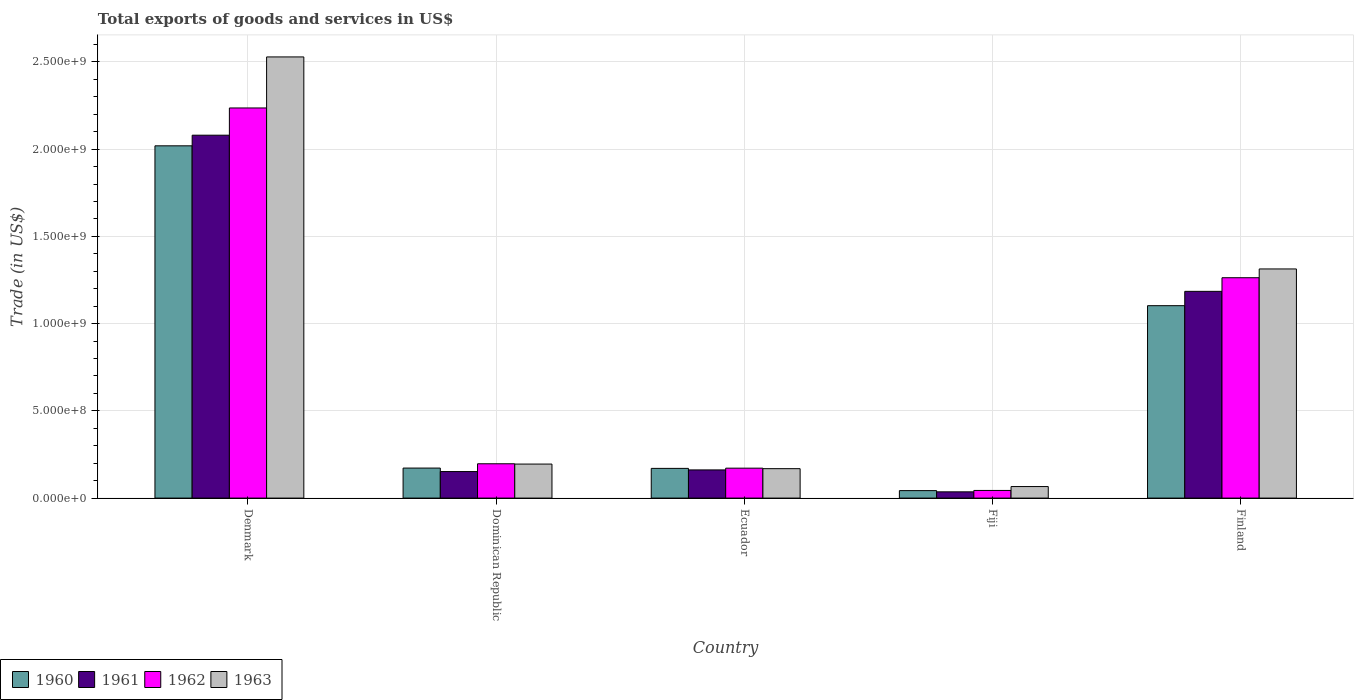How many different coloured bars are there?
Your answer should be compact. 4. How many groups of bars are there?
Offer a very short reply. 5. Are the number of bars on each tick of the X-axis equal?
Ensure brevity in your answer.  Yes. How many bars are there on the 3rd tick from the left?
Offer a terse response. 4. How many bars are there on the 2nd tick from the right?
Your response must be concise. 4. In how many cases, is the number of bars for a given country not equal to the number of legend labels?
Offer a very short reply. 0. What is the total exports of goods and services in 1962 in Fiji?
Make the answer very short. 4.38e+07. Across all countries, what is the maximum total exports of goods and services in 1962?
Provide a short and direct response. 2.24e+09. Across all countries, what is the minimum total exports of goods and services in 1961?
Provide a succinct answer. 3.59e+07. In which country was the total exports of goods and services in 1962 minimum?
Give a very brief answer. Fiji. What is the total total exports of goods and services in 1962 in the graph?
Keep it short and to the point. 3.91e+09. What is the difference between the total exports of goods and services in 1961 in Ecuador and that in Fiji?
Your answer should be very brief. 1.26e+08. What is the difference between the total exports of goods and services in 1963 in Ecuador and the total exports of goods and services in 1960 in Denmark?
Offer a very short reply. -1.85e+09. What is the average total exports of goods and services in 1961 per country?
Provide a succinct answer. 7.23e+08. What is the difference between the total exports of goods and services of/in 1960 and total exports of goods and services of/in 1962 in Denmark?
Give a very brief answer. -2.17e+08. What is the ratio of the total exports of goods and services in 1962 in Denmark to that in Dominican Republic?
Ensure brevity in your answer.  11.37. Is the difference between the total exports of goods and services in 1960 in Dominican Republic and Finland greater than the difference between the total exports of goods and services in 1962 in Dominican Republic and Finland?
Provide a succinct answer. Yes. What is the difference between the highest and the second highest total exports of goods and services in 1960?
Offer a very short reply. -9.31e+08. What is the difference between the highest and the lowest total exports of goods and services in 1960?
Your answer should be very brief. 1.98e+09. In how many countries, is the total exports of goods and services in 1961 greater than the average total exports of goods and services in 1961 taken over all countries?
Keep it short and to the point. 2. Is the sum of the total exports of goods and services in 1961 in Fiji and Finland greater than the maximum total exports of goods and services in 1963 across all countries?
Make the answer very short. No. Is it the case that in every country, the sum of the total exports of goods and services in 1962 and total exports of goods and services in 1961 is greater than the sum of total exports of goods and services in 1960 and total exports of goods and services in 1963?
Your answer should be very brief. No. What does the 3rd bar from the right in Finland represents?
Ensure brevity in your answer.  1961. How many bars are there?
Offer a terse response. 20. Does the graph contain any zero values?
Make the answer very short. No. Does the graph contain grids?
Your answer should be very brief. Yes. Where does the legend appear in the graph?
Provide a succinct answer. Bottom left. How are the legend labels stacked?
Keep it short and to the point. Horizontal. What is the title of the graph?
Provide a succinct answer. Total exports of goods and services in US$. What is the label or title of the Y-axis?
Your response must be concise. Trade (in US$). What is the Trade (in US$) in 1960 in Denmark?
Ensure brevity in your answer.  2.02e+09. What is the Trade (in US$) of 1961 in Denmark?
Provide a short and direct response. 2.08e+09. What is the Trade (in US$) in 1962 in Denmark?
Offer a terse response. 2.24e+09. What is the Trade (in US$) in 1963 in Denmark?
Offer a terse response. 2.53e+09. What is the Trade (in US$) in 1960 in Dominican Republic?
Ensure brevity in your answer.  1.72e+08. What is the Trade (in US$) in 1961 in Dominican Republic?
Make the answer very short. 1.52e+08. What is the Trade (in US$) in 1962 in Dominican Republic?
Your response must be concise. 1.97e+08. What is the Trade (in US$) in 1963 in Dominican Republic?
Give a very brief answer. 1.95e+08. What is the Trade (in US$) in 1960 in Ecuador?
Provide a short and direct response. 1.70e+08. What is the Trade (in US$) of 1961 in Ecuador?
Offer a very short reply. 1.61e+08. What is the Trade (in US$) of 1962 in Ecuador?
Offer a very short reply. 1.71e+08. What is the Trade (in US$) in 1963 in Ecuador?
Make the answer very short. 1.69e+08. What is the Trade (in US$) in 1960 in Fiji?
Offer a terse response. 4.28e+07. What is the Trade (in US$) of 1961 in Fiji?
Provide a succinct answer. 3.59e+07. What is the Trade (in US$) in 1962 in Fiji?
Offer a very short reply. 4.38e+07. What is the Trade (in US$) in 1963 in Fiji?
Your answer should be very brief. 6.61e+07. What is the Trade (in US$) in 1960 in Finland?
Your response must be concise. 1.10e+09. What is the Trade (in US$) in 1961 in Finland?
Offer a terse response. 1.18e+09. What is the Trade (in US$) in 1962 in Finland?
Your response must be concise. 1.26e+09. What is the Trade (in US$) of 1963 in Finland?
Provide a short and direct response. 1.31e+09. Across all countries, what is the maximum Trade (in US$) in 1960?
Keep it short and to the point. 2.02e+09. Across all countries, what is the maximum Trade (in US$) in 1961?
Provide a short and direct response. 2.08e+09. Across all countries, what is the maximum Trade (in US$) of 1962?
Give a very brief answer. 2.24e+09. Across all countries, what is the maximum Trade (in US$) in 1963?
Keep it short and to the point. 2.53e+09. Across all countries, what is the minimum Trade (in US$) of 1960?
Ensure brevity in your answer.  4.28e+07. Across all countries, what is the minimum Trade (in US$) of 1961?
Provide a short and direct response. 3.59e+07. Across all countries, what is the minimum Trade (in US$) in 1962?
Make the answer very short. 4.38e+07. Across all countries, what is the minimum Trade (in US$) in 1963?
Provide a short and direct response. 6.61e+07. What is the total Trade (in US$) of 1960 in the graph?
Offer a very short reply. 3.51e+09. What is the total Trade (in US$) of 1961 in the graph?
Your answer should be compact. 3.61e+09. What is the total Trade (in US$) of 1962 in the graph?
Your answer should be very brief. 3.91e+09. What is the total Trade (in US$) in 1963 in the graph?
Your answer should be very brief. 4.27e+09. What is the difference between the Trade (in US$) of 1960 in Denmark and that in Dominican Republic?
Offer a very short reply. 1.85e+09. What is the difference between the Trade (in US$) in 1961 in Denmark and that in Dominican Republic?
Your answer should be compact. 1.93e+09. What is the difference between the Trade (in US$) of 1962 in Denmark and that in Dominican Republic?
Make the answer very short. 2.04e+09. What is the difference between the Trade (in US$) in 1963 in Denmark and that in Dominican Republic?
Offer a very short reply. 2.33e+09. What is the difference between the Trade (in US$) of 1960 in Denmark and that in Ecuador?
Offer a very short reply. 1.85e+09. What is the difference between the Trade (in US$) of 1961 in Denmark and that in Ecuador?
Provide a short and direct response. 1.92e+09. What is the difference between the Trade (in US$) of 1962 in Denmark and that in Ecuador?
Your response must be concise. 2.06e+09. What is the difference between the Trade (in US$) of 1963 in Denmark and that in Ecuador?
Your response must be concise. 2.36e+09. What is the difference between the Trade (in US$) of 1960 in Denmark and that in Fiji?
Provide a succinct answer. 1.98e+09. What is the difference between the Trade (in US$) of 1961 in Denmark and that in Fiji?
Keep it short and to the point. 2.04e+09. What is the difference between the Trade (in US$) in 1962 in Denmark and that in Fiji?
Keep it short and to the point. 2.19e+09. What is the difference between the Trade (in US$) in 1963 in Denmark and that in Fiji?
Keep it short and to the point. 2.46e+09. What is the difference between the Trade (in US$) in 1960 in Denmark and that in Finland?
Ensure brevity in your answer.  9.16e+08. What is the difference between the Trade (in US$) of 1961 in Denmark and that in Finland?
Make the answer very short. 8.95e+08. What is the difference between the Trade (in US$) in 1962 in Denmark and that in Finland?
Your answer should be very brief. 9.73e+08. What is the difference between the Trade (in US$) of 1963 in Denmark and that in Finland?
Keep it short and to the point. 1.22e+09. What is the difference between the Trade (in US$) in 1960 in Dominican Republic and that in Ecuador?
Offer a terse response. 1.84e+06. What is the difference between the Trade (in US$) in 1961 in Dominican Republic and that in Ecuador?
Keep it short and to the point. -9.39e+06. What is the difference between the Trade (in US$) in 1962 in Dominican Republic and that in Ecuador?
Your response must be concise. 2.52e+07. What is the difference between the Trade (in US$) of 1963 in Dominican Republic and that in Ecuador?
Your response must be concise. 2.63e+07. What is the difference between the Trade (in US$) in 1960 in Dominican Republic and that in Fiji?
Provide a succinct answer. 1.29e+08. What is the difference between the Trade (in US$) of 1961 in Dominican Republic and that in Fiji?
Ensure brevity in your answer.  1.16e+08. What is the difference between the Trade (in US$) of 1962 in Dominican Republic and that in Fiji?
Your answer should be very brief. 1.53e+08. What is the difference between the Trade (in US$) in 1963 in Dominican Republic and that in Fiji?
Provide a short and direct response. 1.29e+08. What is the difference between the Trade (in US$) of 1960 in Dominican Republic and that in Finland?
Your response must be concise. -9.31e+08. What is the difference between the Trade (in US$) in 1961 in Dominican Republic and that in Finland?
Keep it short and to the point. -1.03e+09. What is the difference between the Trade (in US$) in 1962 in Dominican Republic and that in Finland?
Your response must be concise. -1.07e+09. What is the difference between the Trade (in US$) of 1963 in Dominican Republic and that in Finland?
Offer a very short reply. -1.12e+09. What is the difference between the Trade (in US$) of 1960 in Ecuador and that in Fiji?
Your answer should be compact. 1.27e+08. What is the difference between the Trade (in US$) in 1961 in Ecuador and that in Fiji?
Keep it short and to the point. 1.26e+08. What is the difference between the Trade (in US$) of 1962 in Ecuador and that in Fiji?
Provide a short and direct response. 1.28e+08. What is the difference between the Trade (in US$) in 1963 in Ecuador and that in Fiji?
Your answer should be compact. 1.03e+08. What is the difference between the Trade (in US$) of 1960 in Ecuador and that in Finland?
Offer a very short reply. -9.33e+08. What is the difference between the Trade (in US$) in 1961 in Ecuador and that in Finland?
Provide a succinct answer. -1.02e+09. What is the difference between the Trade (in US$) in 1962 in Ecuador and that in Finland?
Provide a short and direct response. -1.09e+09. What is the difference between the Trade (in US$) of 1963 in Ecuador and that in Finland?
Your answer should be compact. -1.14e+09. What is the difference between the Trade (in US$) in 1960 in Fiji and that in Finland?
Your response must be concise. -1.06e+09. What is the difference between the Trade (in US$) of 1961 in Fiji and that in Finland?
Your answer should be compact. -1.15e+09. What is the difference between the Trade (in US$) of 1962 in Fiji and that in Finland?
Your answer should be very brief. -1.22e+09. What is the difference between the Trade (in US$) of 1963 in Fiji and that in Finland?
Offer a very short reply. -1.25e+09. What is the difference between the Trade (in US$) in 1960 in Denmark and the Trade (in US$) in 1961 in Dominican Republic?
Provide a short and direct response. 1.87e+09. What is the difference between the Trade (in US$) in 1960 in Denmark and the Trade (in US$) in 1962 in Dominican Republic?
Your answer should be very brief. 1.82e+09. What is the difference between the Trade (in US$) of 1960 in Denmark and the Trade (in US$) of 1963 in Dominican Republic?
Provide a succinct answer. 1.82e+09. What is the difference between the Trade (in US$) of 1961 in Denmark and the Trade (in US$) of 1962 in Dominican Republic?
Offer a terse response. 1.88e+09. What is the difference between the Trade (in US$) of 1961 in Denmark and the Trade (in US$) of 1963 in Dominican Republic?
Your answer should be very brief. 1.88e+09. What is the difference between the Trade (in US$) in 1962 in Denmark and the Trade (in US$) in 1963 in Dominican Republic?
Provide a short and direct response. 2.04e+09. What is the difference between the Trade (in US$) in 1960 in Denmark and the Trade (in US$) in 1961 in Ecuador?
Give a very brief answer. 1.86e+09. What is the difference between the Trade (in US$) in 1960 in Denmark and the Trade (in US$) in 1962 in Ecuador?
Keep it short and to the point. 1.85e+09. What is the difference between the Trade (in US$) of 1960 in Denmark and the Trade (in US$) of 1963 in Ecuador?
Give a very brief answer. 1.85e+09. What is the difference between the Trade (in US$) of 1961 in Denmark and the Trade (in US$) of 1962 in Ecuador?
Offer a terse response. 1.91e+09. What is the difference between the Trade (in US$) of 1961 in Denmark and the Trade (in US$) of 1963 in Ecuador?
Make the answer very short. 1.91e+09. What is the difference between the Trade (in US$) of 1962 in Denmark and the Trade (in US$) of 1963 in Ecuador?
Make the answer very short. 2.07e+09. What is the difference between the Trade (in US$) of 1960 in Denmark and the Trade (in US$) of 1961 in Fiji?
Your answer should be very brief. 1.98e+09. What is the difference between the Trade (in US$) in 1960 in Denmark and the Trade (in US$) in 1962 in Fiji?
Provide a succinct answer. 1.98e+09. What is the difference between the Trade (in US$) of 1960 in Denmark and the Trade (in US$) of 1963 in Fiji?
Provide a short and direct response. 1.95e+09. What is the difference between the Trade (in US$) of 1961 in Denmark and the Trade (in US$) of 1962 in Fiji?
Offer a terse response. 2.04e+09. What is the difference between the Trade (in US$) in 1961 in Denmark and the Trade (in US$) in 1963 in Fiji?
Offer a terse response. 2.01e+09. What is the difference between the Trade (in US$) in 1962 in Denmark and the Trade (in US$) in 1963 in Fiji?
Offer a terse response. 2.17e+09. What is the difference between the Trade (in US$) of 1960 in Denmark and the Trade (in US$) of 1961 in Finland?
Make the answer very short. 8.34e+08. What is the difference between the Trade (in US$) of 1960 in Denmark and the Trade (in US$) of 1962 in Finland?
Give a very brief answer. 7.56e+08. What is the difference between the Trade (in US$) of 1960 in Denmark and the Trade (in US$) of 1963 in Finland?
Provide a succinct answer. 7.06e+08. What is the difference between the Trade (in US$) of 1961 in Denmark and the Trade (in US$) of 1962 in Finland?
Your answer should be very brief. 8.17e+08. What is the difference between the Trade (in US$) in 1961 in Denmark and the Trade (in US$) in 1963 in Finland?
Your answer should be very brief. 7.67e+08. What is the difference between the Trade (in US$) of 1962 in Denmark and the Trade (in US$) of 1963 in Finland?
Offer a terse response. 9.23e+08. What is the difference between the Trade (in US$) of 1960 in Dominican Republic and the Trade (in US$) of 1961 in Ecuador?
Keep it short and to the point. 1.06e+07. What is the difference between the Trade (in US$) of 1960 in Dominican Republic and the Trade (in US$) of 1962 in Ecuador?
Your answer should be compact. 6.09e+05. What is the difference between the Trade (in US$) of 1960 in Dominican Republic and the Trade (in US$) of 1963 in Ecuador?
Your response must be concise. 3.40e+06. What is the difference between the Trade (in US$) of 1961 in Dominican Republic and the Trade (in US$) of 1962 in Ecuador?
Make the answer very short. -1.94e+07. What is the difference between the Trade (in US$) of 1961 in Dominican Republic and the Trade (in US$) of 1963 in Ecuador?
Your answer should be compact. -1.66e+07. What is the difference between the Trade (in US$) in 1962 in Dominican Republic and the Trade (in US$) in 1963 in Ecuador?
Offer a very short reply. 2.80e+07. What is the difference between the Trade (in US$) in 1960 in Dominican Republic and the Trade (in US$) in 1961 in Fiji?
Offer a very short reply. 1.36e+08. What is the difference between the Trade (in US$) in 1960 in Dominican Republic and the Trade (in US$) in 1962 in Fiji?
Offer a terse response. 1.28e+08. What is the difference between the Trade (in US$) in 1960 in Dominican Republic and the Trade (in US$) in 1963 in Fiji?
Offer a terse response. 1.06e+08. What is the difference between the Trade (in US$) in 1961 in Dominican Republic and the Trade (in US$) in 1962 in Fiji?
Provide a succinct answer. 1.08e+08. What is the difference between the Trade (in US$) in 1961 in Dominican Republic and the Trade (in US$) in 1963 in Fiji?
Ensure brevity in your answer.  8.60e+07. What is the difference between the Trade (in US$) of 1962 in Dominican Republic and the Trade (in US$) of 1963 in Fiji?
Offer a very short reply. 1.31e+08. What is the difference between the Trade (in US$) in 1960 in Dominican Republic and the Trade (in US$) in 1961 in Finland?
Your answer should be compact. -1.01e+09. What is the difference between the Trade (in US$) of 1960 in Dominican Republic and the Trade (in US$) of 1962 in Finland?
Provide a succinct answer. -1.09e+09. What is the difference between the Trade (in US$) of 1960 in Dominican Republic and the Trade (in US$) of 1963 in Finland?
Provide a short and direct response. -1.14e+09. What is the difference between the Trade (in US$) of 1961 in Dominican Republic and the Trade (in US$) of 1962 in Finland?
Offer a terse response. -1.11e+09. What is the difference between the Trade (in US$) of 1961 in Dominican Republic and the Trade (in US$) of 1963 in Finland?
Offer a very short reply. -1.16e+09. What is the difference between the Trade (in US$) of 1962 in Dominican Republic and the Trade (in US$) of 1963 in Finland?
Keep it short and to the point. -1.12e+09. What is the difference between the Trade (in US$) in 1960 in Ecuador and the Trade (in US$) in 1961 in Fiji?
Your response must be concise. 1.34e+08. What is the difference between the Trade (in US$) in 1960 in Ecuador and the Trade (in US$) in 1962 in Fiji?
Your response must be concise. 1.26e+08. What is the difference between the Trade (in US$) of 1960 in Ecuador and the Trade (in US$) of 1963 in Fiji?
Make the answer very short. 1.04e+08. What is the difference between the Trade (in US$) in 1961 in Ecuador and the Trade (in US$) in 1962 in Fiji?
Your response must be concise. 1.18e+08. What is the difference between the Trade (in US$) in 1961 in Ecuador and the Trade (in US$) in 1963 in Fiji?
Ensure brevity in your answer.  9.54e+07. What is the difference between the Trade (in US$) of 1962 in Ecuador and the Trade (in US$) of 1963 in Fiji?
Keep it short and to the point. 1.05e+08. What is the difference between the Trade (in US$) in 1960 in Ecuador and the Trade (in US$) in 1961 in Finland?
Keep it short and to the point. -1.01e+09. What is the difference between the Trade (in US$) of 1960 in Ecuador and the Trade (in US$) of 1962 in Finland?
Provide a short and direct response. -1.09e+09. What is the difference between the Trade (in US$) in 1960 in Ecuador and the Trade (in US$) in 1963 in Finland?
Give a very brief answer. -1.14e+09. What is the difference between the Trade (in US$) of 1961 in Ecuador and the Trade (in US$) of 1962 in Finland?
Provide a short and direct response. -1.10e+09. What is the difference between the Trade (in US$) of 1961 in Ecuador and the Trade (in US$) of 1963 in Finland?
Provide a short and direct response. -1.15e+09. What is the difference between the Trade (in US$) of 1962 in Ecuador and the Trade (in US$) of 1963 in Finland?
Ensure brevity in your answer.  -1.14e+09. What is the difference between the Trade (in US$) in 1960 in Fiji and the Trade (in US$) in 1961 in Finland?
Offer a very short reply. -1.14e+09. What is the difference between the Trade (in US$) of 1960 in Fiji and the Trade (in US$) of 1962 in Finland?
Ensure brevity in your answer.  -1.22e+09. What is the difference between the Trade (in US$) of 1960 in Fiji and the Trade (in US$) of 1963 in Finland?
Give a very brief answer. -1.27e+09. What is the difference between the Trade (in US$) in 1961 in Fiji and the Trade (in US$) in 1962 in Finland?
Offer a terse response. -1.23e+09. What is the difference between the Trade (in US$) in 1961 in Fiji and the Trade (in US$) in 1963 in Finland?
Offer a very short reply. -1.28e+09. What is the difference between the Trade (in US$) of 1962 in Fiji and the Trade (in US$) of 1963 in Finland?
Your answer should be compact. -1.27e+09. What is the average Trade (in US$) in 1960 per country?
Offer a very short reply. 7.01e+08. What is the average Trade (in US$) in 1961 per country?
Give a very brief answer. 7.23e+08. What is the average Trade (in US$) of 1962 per country?
Ensure brevity in your answer.  7.82e+08. What is the average Trade (in US$) of 1963 per country?
Make the answer very short. 8.54e+08. What is the difference between the Trade (in US$) of 1960 and Trade (in US$) of 1961 in Denmark?
Your answer should be compact. -6.09e+07. What is the difference between the Trade (in US$) of 1960 and Trade (in US$) of 1962 in Denmark?
Your answer should be very brief. -2.17e+08. What is the difference between the Trade (in US$) in 1960 and Trade (in US$) in 1963 in Denmark?
Offer a terse response. -5.09e+08. What is the difference between the Trade (in US$) in 1961 and Trade (in US$) in 1962 in Denmark?
Your answer should be compact. -1.56e+08. What is the difference between the Trade (in US$) of 1961 and Trade (in US$) of 1963 in Denmark?
Provide a short and direct response. -4.49e+08. What is the difference between the Trade (in US$) in 1962 and Trade (in US$) in 1963 in Denmark?
Your answer should be very brief. -2.92e+08. What is the difference between the Trade (in US$) of 1960 and Trade (in US$) of 1962 in Dominican Republic?
Ensure brevity in your answer.  -2.46e+07. What is the difference between the Trade (in US$) of 1960 and Trade (in US$) of 1963 in Dominican Republic?
Provide a short and direct response. -2.29e+07. What is the difference between the Trade (in US$) of 1961 and Trade (in US$) of 1962 in Dominican Republic?
Your answer should be very brief. -4.46e+07. What is the difference between the Trade (in US$) of 1961 and Trade (in US$) of 1963 in Dominican Republic?
Your response must be concise. -4.29e+07. What is the difference between the Trade (in US$) of 1962 and Trade (in US$) of 1963 in Dominican Republic?
Offer a terse response. 1.70e+06. What is the difference between the Trade (in US$) in 1960 and Trade (in US$) in 1961 in Ecuador?
Your answer should be compact. 8.78e+06. What is the difference between the Trade (in US$) of 1960 and Trade (in US$) of 1962 in Ecuador?
Give a very brief answer. -1.23e+06. What is the difference between the Trade (in US$) of 1960 and Trade (in US$) of 1963 in Ecuador?
Offer a terse response. 1.56e+06. What is the difference between the Trade (in US$) of 1961 and Trade (in US$) of 1962 in Ecuador?
Make the answer very short. -1.00e+07. What is the difference between the Trade (in US$) of 1961 and Trade (in US$) of 1963 in Ecuador?
Make the answer very short. -7.21e+06. What is the difference between the Trade (in US$) in 1962 and Trade (in US$) in 1963 in Ecuador?
Offer a terse response. 2.79e+06. What is the difference between the Trade (in US$) of 1960 and Trade (in US$) of 1961 in Fiji?
Provide a succinct answer. 6.93e+06. What is the difference between the Trade (in US$) of 1960 and Trade (in US$) of 1962 in Fiji?
Provide a short and direct response. -1.01e+06. What is the difference between the Trade (in US$) of 1960 and Trade (in US$) of 1963 in Fiji?
Ensure brevity in your answer.  -2.33e+07. What is the difference between the Trade (in US$) in 1961 and Trade (in US$) in 1962 in Fiji?
Give a very brief answer. -7.93e+06. What is the difference between the Trade (in US$) of 1961 and Trade (in US$) of 1963 in Fiji?
Your answer should be compact. -3.02e+07. What is the difference between the Trade (in US$) in 1962 and Trade (in US$) in 1963 in Fiji?
Keep it short and to the point. -2.23e+07. What is the difference between the Trade (in US$) in 1960 and Trade (in US$) in 1961 in Finland?
Give a very brief answer. -8.21e+07. What is the difference between the Trade (in US$) in 1960 and Trade (in US$) in 1962 in Finland?
Your answer should be very brief. -1.60e+08. What is the difference between the Trade (in US$) of 1960 and Trade (in US$) of 1963 in Finland?
Provide a short and direct response. -2.11e+08. What is the difference between the Trade (in US$) in 1961 and Trade (in US$) in 1962 in Finland?
Give a very brief answer. -7.82e+07. What is the difference between the Trade (in US$) of 1961 and Trade (in US$) of 1963 in Finland?
Keep it short and to the point. -1.28e+08. What is the difference between the Trade (in US$) in 1962 and Trade (in US$) in 1963 in Finland?
Give a very brief answer. -5.03e+07. What is the ratio of the Trade (in US$) in 1960 in Denmark to that in Dominican Republic?
Your answer should be very brief. 11.73. What is the ratio of the Trade (in US$) in 1961 in Denmark to that in Dominican Republic?
Your answer should be very brief. 13.67. What is the ratio of the Trade (in US$) in 1962 in Denmark to that in Dominican Republic?
Ensure brevity in your answer.  11.37. What is the ratio of the Trade (in US$) of 1963 in Denmark to that in Dominican Republic?
Provide a succinct answer. 12.97. What is the ratio of the Trade (in US$) of 1960 in Denmark to that in Ecuador?
Your answer should be compact. 11.86. What is the ratio of the Trade (in US$) of 1961 in Denmark to that in Ecuador?
Provide a succinct answer. 12.88. What is the ratio of the Trade (in US$) in 1962 in Denmark to that in Ecuador?
Offer a terse response. 13.04. What is the ratio of the Trade (in US$) in 1963 in Denmark to that in Ecuador?
Your answer should be compact. 14.99. What is the ratio of the Trade (in US$) in 1960 in Denmark to that in Fiji?
Give a very brief answer. 47.15. What is the ratio of the Trade (in US$) of 1961 in Denmark to that in Fiji?
Keep it short and to the point. 57.95. What is the ratio of the Trade (in US$) of 1962 in Denmark to that in Fiji?
Your answer should be compact. 51.02. What is the ratio of the Trade (in US$) in 1963 in Denmark to that in Fiji?
Provide a succinct answer. 38.24. What is the ratio of the Trade (in US$) of 1960 in Denmark to that in Finland?
Give a very brief answer. 1.83. What is the ratio of the Trade (in US$) in 1961 in Denmark to that in Finland?
Make the answer very short. 1.76. What is the ratio of the Trade (in US$) of 1962 in Denmark to that in Finland?
Offer a very short reply. 1.77. What is the ratio of the Trade (in US$) in 1963 in Denmark to that in Finland?
Provide a short and direct response. 1.93. What is the ratio of the Trade (in US$) of 1960 in Dominican Republic to that in Ecuador?
Ensure brevity in your answer.  1.01. What is the ratio of the Trade (in US$) in 1961 in Dominican Republic to that in Ecuador?
Your answer should be very brief. 0.94. What is the ratio of the Trade (in US$) of 1962 in Dominican Republic to that in Ecuador?
Provide a succinct answer. 1.15. What is the ratio of the Trade (in US$) in 1963 in Dominican Republic to that in Ecuador?
Offer a terse response. 1.16. What is the ratio of the Trade (in US$) in 1960 in Dominican Republic to that in Fiji?
Your response must be concise. 4.02. What is the ratio of the Trade (in US$) in 1961 in Dominican Republic to that in Fiji?
Give a very brief answer. 4.24. What is the ratio of the Trade (in US$) in 1962 in Dominican Republic to that in Fiji?
Provide a succinct answer. 4.49. What is the ratio of the Trade (in US$) of 1963 in Dominican Republic to that in Fiji?
Give a very brief answer. 2.95. What is the ratio of the Trade (in US$) of 1960 in Dominican Republic to that in Finland?
Keep it short and to the point. 0.16. What is the ratio of the Trade (in US$) in 1961 in Dominican Republic to that in Finland?
Keep it short and to the point. 0.13. What is the ratio of the Trade (in US$) in 1962 in Dominican Republic to that in Finland?
Offer a very short reply. 0.16. What is the ratio of the Trade (in US$) in 1963 in Dominican Republic to that in Finland?
Your answer should be compact. 0.15. What is the ratio of the Trade (in US$) of 1960 in Ecuador to that in Fiji?
Ensure brevity in your answer.  3.98. What is the ratio of the Trade (in US$) of 1961 in Ecuador to that in Fiji?
Make the answer very short. 4.5. What is the ratio of the Trade (in US$) of 1962 in Ecuador to that in Fiji?
Make the answer very short. 3.91. What is the ratio of the Trade (in US$) of 1963 in Ecuador to that in Fiji?
Offer a terse response. 2.55. What is the ratio of the Trade (in US$) in 1960 in Ecuador to that in Finland?
Make the answer very short. 0.15. What is the ratio of the Trade (in US$) in 1961 in Ecuador to that in Finland?
Your answer should be very brief. 0.14. What is the ratio of the Trade (in US$) in 1962 in Ecuador to that in Finland?
Ensure brevity in your answer.  0.14. What is the ratio of the Trade (in US$) in 1963 in Ecuador to that in Finland?
Offer a terse response. 0.13. What is the ratio of the Trade (in US$) of 1960 in Fiji to that in Finland?
Offer a very short reply. 0.04. What is the ratio of the Trade (in US$) of 1961 in Fiji to that in Finland?
Offer a very short reply. 0.03. What is the ratio of the Trade (in US$) in 1962 in Fiji to that in Finland?
Your answer should be compact. 0.03. What is the ratio of the Trade (in US$) in 1963 in Fiji to that in Finland?
Offer a terse response. 0.05. What is the difference between the highest and the second highest Trade (in US$) of 1960?
Provide a short and direct response. 9.16e+08. What is the difference between the highest and the second highest Trade (in US$) in 1961?
Provide a succinct answer. 8.95e+08. What is the difference between the highest and the second highest Trade (in US$) in 1962?
Keep it short and to the point. 9.73e+08. What is the difference between the highest and the second highest Trade (in US$) in 1963?
Provide a short and direct response. 1.22e+09. What is the difference between the highest and the lowest Trade (in US$) of 1960?
Provide a succinct answer. 1.98e+09. What is the difference between the highest and the lowest Trade (in US$) in 1961?
Provide a succinct answer. 2.04e+09. What is the difference between the highest and the lowest Trade (in US$) in 1962?
Ensure brevity in your answer.  2.19e+09. What is the difference between the highest and the lowest Trade (in US$) in 1963?
Keep it short and to the point. 2.46e+09. 